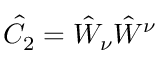<formula> <loc_0><loc_0><loc_500><loc_500>\hat { C } _ { 2 } = \hat { W } _ { \nu } \hat { W } ^ { \nu }</formula> 